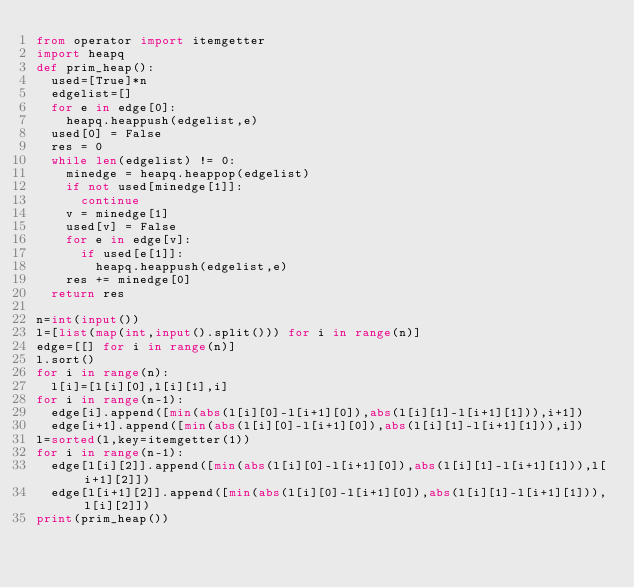<code> <loc_0><loc_0><loc_500><loc_500><_Python_>from operator import itemgetter
import heapq
def prim_heap():
  used=[True]*n
  edgelist=[]
  for e in edge[0]:
    heapq.heappush(edgelist,e)
  used[0] = False
  res = 0
  while len(edgelist) != 0:
    minedge = heapq.heappop(edgelist)
    if not used[minedge[1]]:
      continue
    v = minedge[1]
    used[v] = False
    for e in edge[v]:
      if used[e[1]]:
        heapq.heappush(edgelist,e)
    res += minedge[0]
  return res

n=int(input())
l=[list(map(int,input().split())) for i in range(n)]
edge=[[] for i in range(n)]
l.sort()
for i in range(n):
  l[i]=[l[i][0],l[i][1],i]
for i in range(n-1):
  edge[i].append([min(abs(l[i][0]-l[i+1][0]),abs(l[i][1]-l[i+1][1])),i+1])
  edge[i+1].append([min(abs(l[i][0]-l[i+1][0]),abs(l[i][1]-l[i+1][1])),i])
l=sorted(l,key=itemgetter(1))
for i in range(n-1):
  edge[l[i][2]].append([min(abs(l[i][0]-l[i+1][0]),abs(l[i][1]-l[i+1][1])),l[i+1][2]])
  edge[l[i+1][2]].append([min(abs(l[i][0]-l[i+1][0]),abs(l[i][1]-l[i+1][1])),l[i][2]])
print(prim_heap())</code> 